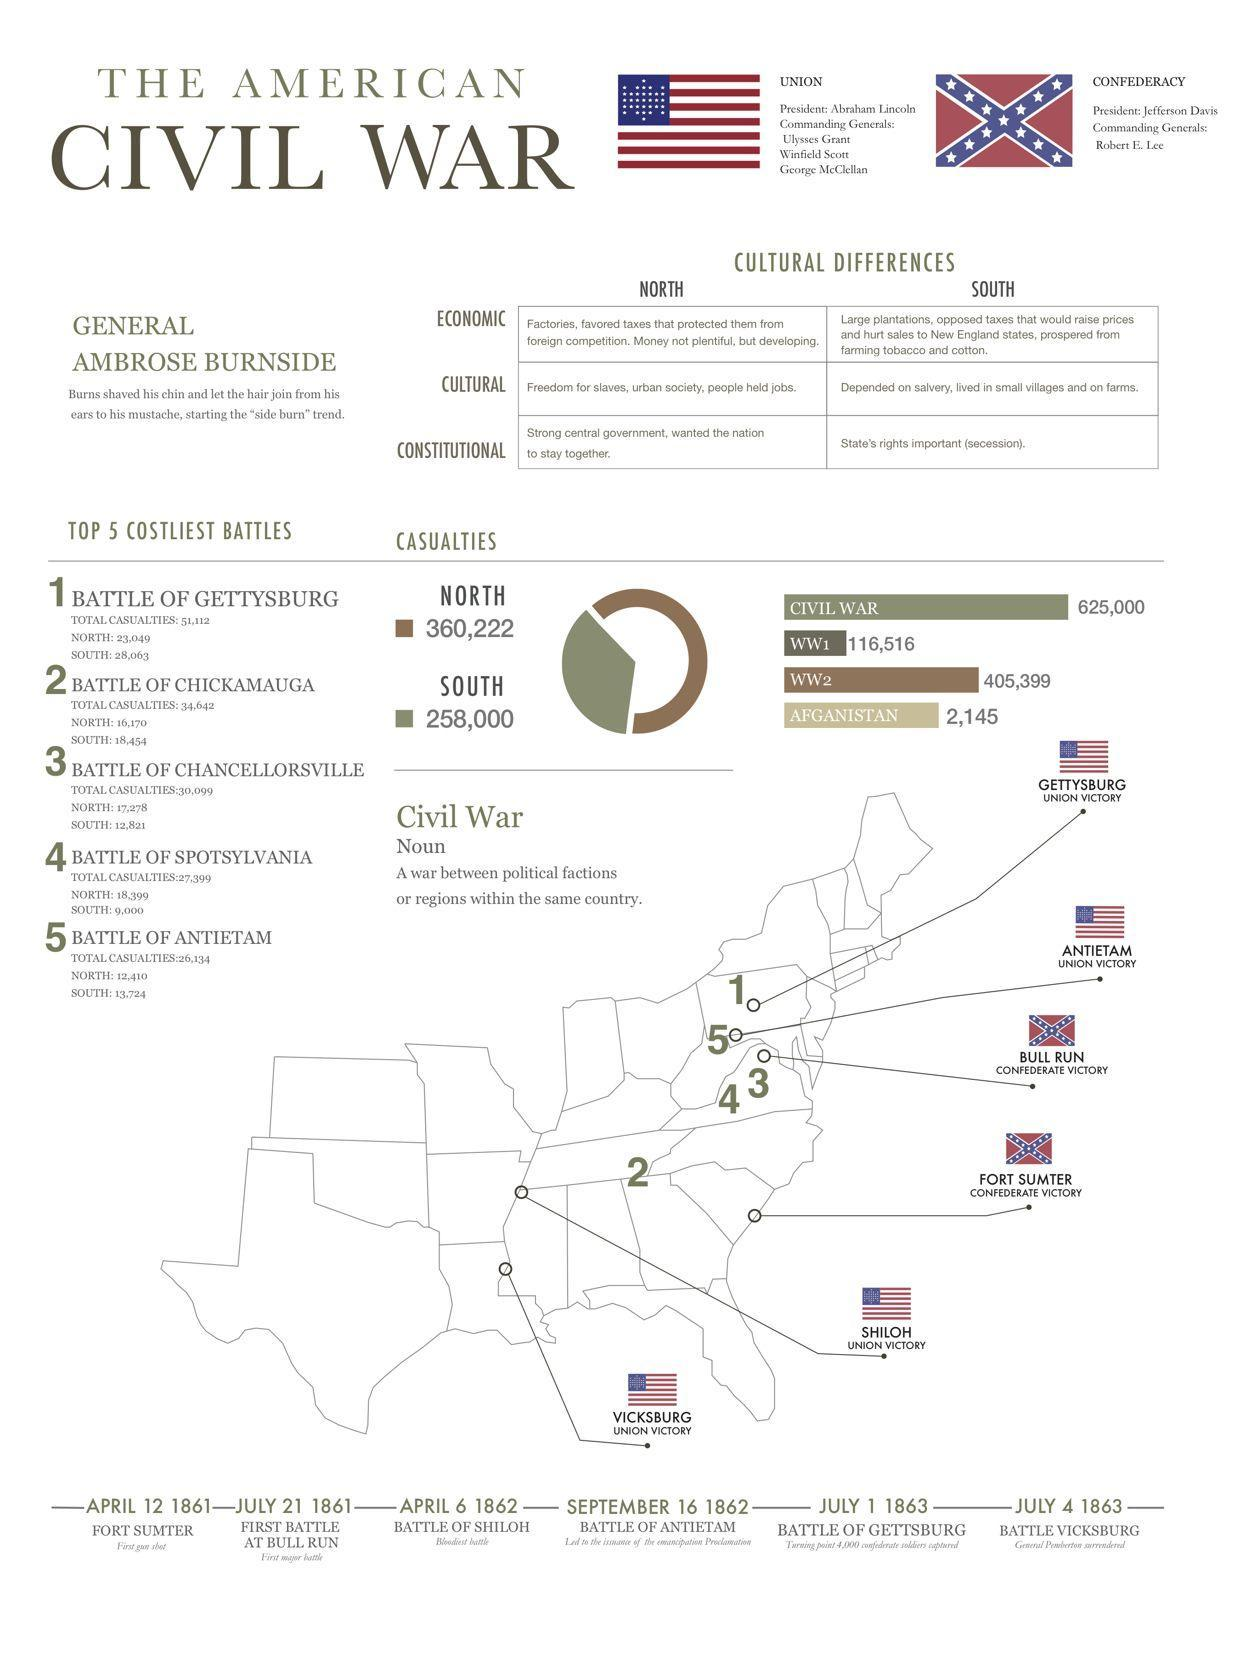what is the number of casualties of South during civil war?
Answer the question with a short phrase. 258000 what is the total casualties of the battle of Gettysburg and the battle of Chickamauga taken together? 85754 which are the battles happened in 1863? battle of Gettsburg, battle of Vicksburg what is the total casualties of the battle of Chancellorsville, battle of Antietam and the battle of Chickamauga taken together? 92140 which region had more casualties in the battle of Spotsylvania - north or south? north which region had more casualties in the battle of Chancellorsville - north or south? north which region had more casualties in the battle of Chickamauga - north or south? south which was the second costliest battle? battle of Chickamauga which are the battles given in this infographic that happened in 1862? battle of Shiloh, battle of Antietam what is the total casualties of the battle of Chancellorsville and the battle of Chickamauga taken together? 64741 which region had more casualties in the battle of Antietam - north or south? south what is the total casualties of the battle of Antietam and the battle of Spotsylvania taken together? 53533 what is the number of casualties of North during civil war? 360222 which battle happened earlier - battle of Antietam or battle of Vicksburg? battle of Antietam which was the third costliest battle? battle of Chancellorsville 